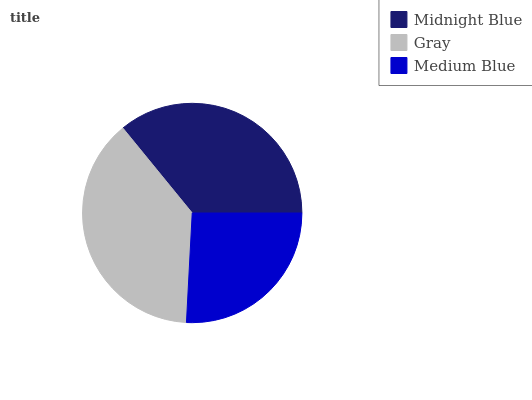Is Medium Blue the minimum?
Answer yes or no. Yes. Is Gray the maximum?
Answer yes or no. Yes. Is Gray the minimum?
Answer yes or no. No. Is Medium Blue the maximum?
Answer yes or no. No. Is Gray greater than Medium Blue?
Answer yes or no. Yes. Is Medium Blue less than Gray?
Answer yes or no. Yes. Is Medium Blue greater than Gray?
Answer yes or no. No. Is Gray less than Medium Blue?
Answer yes or no. No. Is Midnight Blue the high median?
Answer yes or no. Yes. Is Midnight Blue the low median?
Answer yes or no. Yes. Is Gray the high median?
Answer yes or no. No. Is Medium Blue the low median?
Answer yes or no. No. 